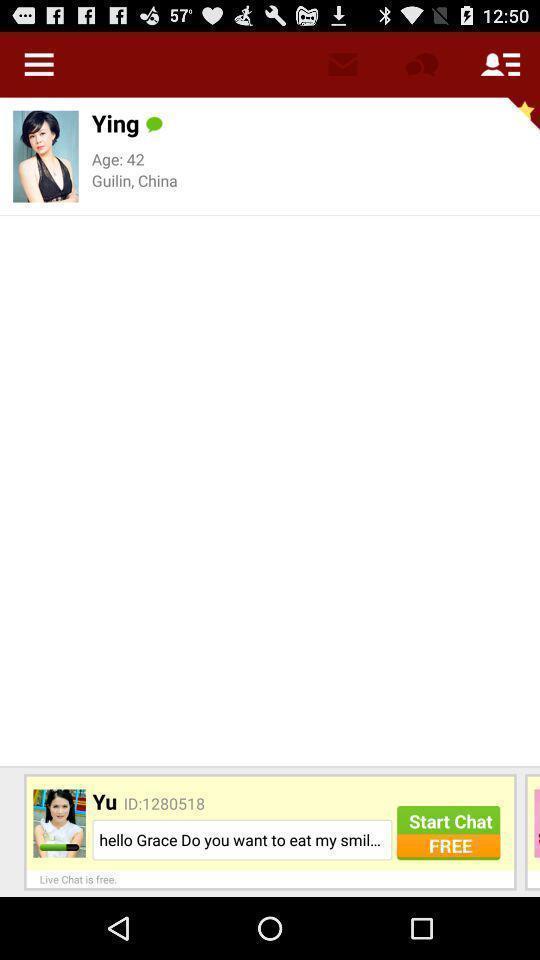Summarize the main components in this picture. Page showing information about a female. 